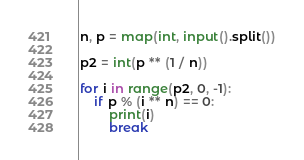<code> <loc_0><loc_0><loc_500><loc_500><_Python_>n, p = map(int, input().split())

p2 = int(p ** (1 / n))

for i in range(p2, 0, -1):
    if p % (i ** n) == 0:
        print(i)
        break</code> 